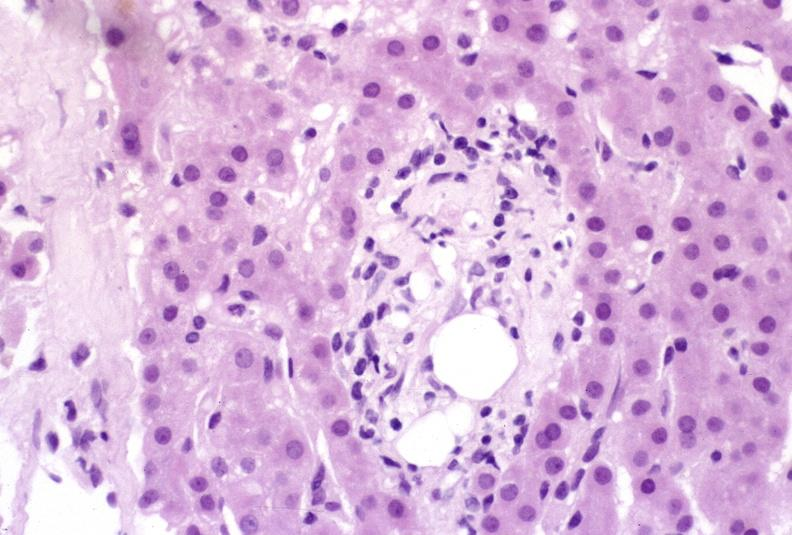s small intestine present?
Answer the question using a single word or phrase. No 